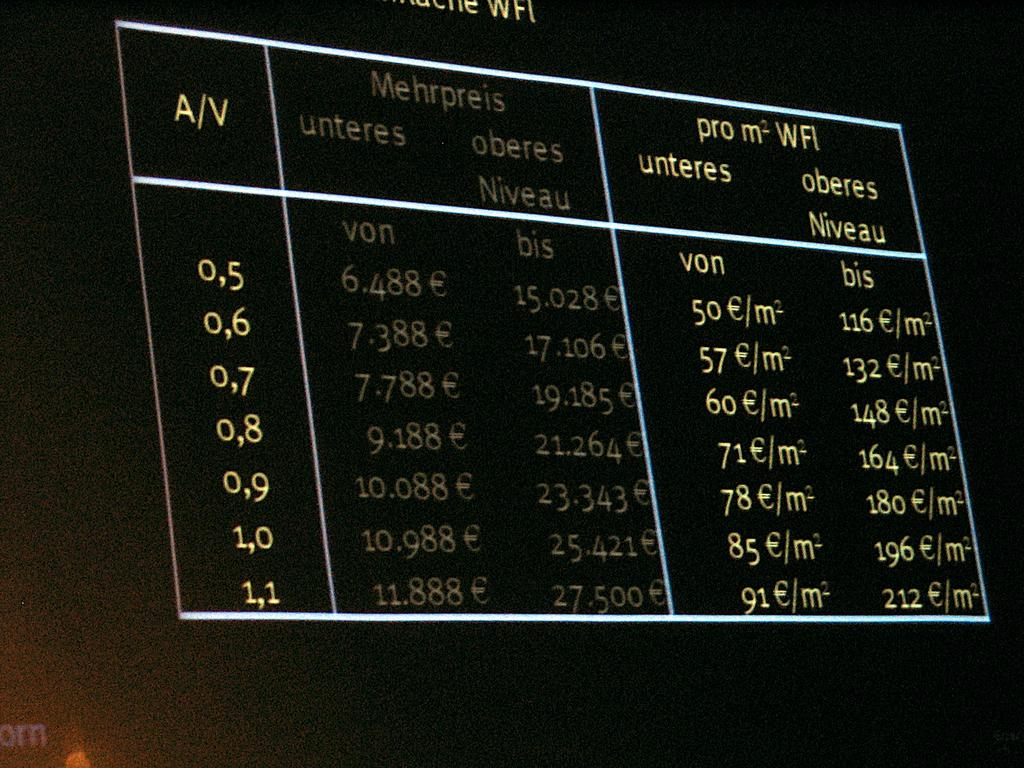<image>
Create a compact narrative representing the image presented. A electronic board displaying Mehrpreis on it in red and green 